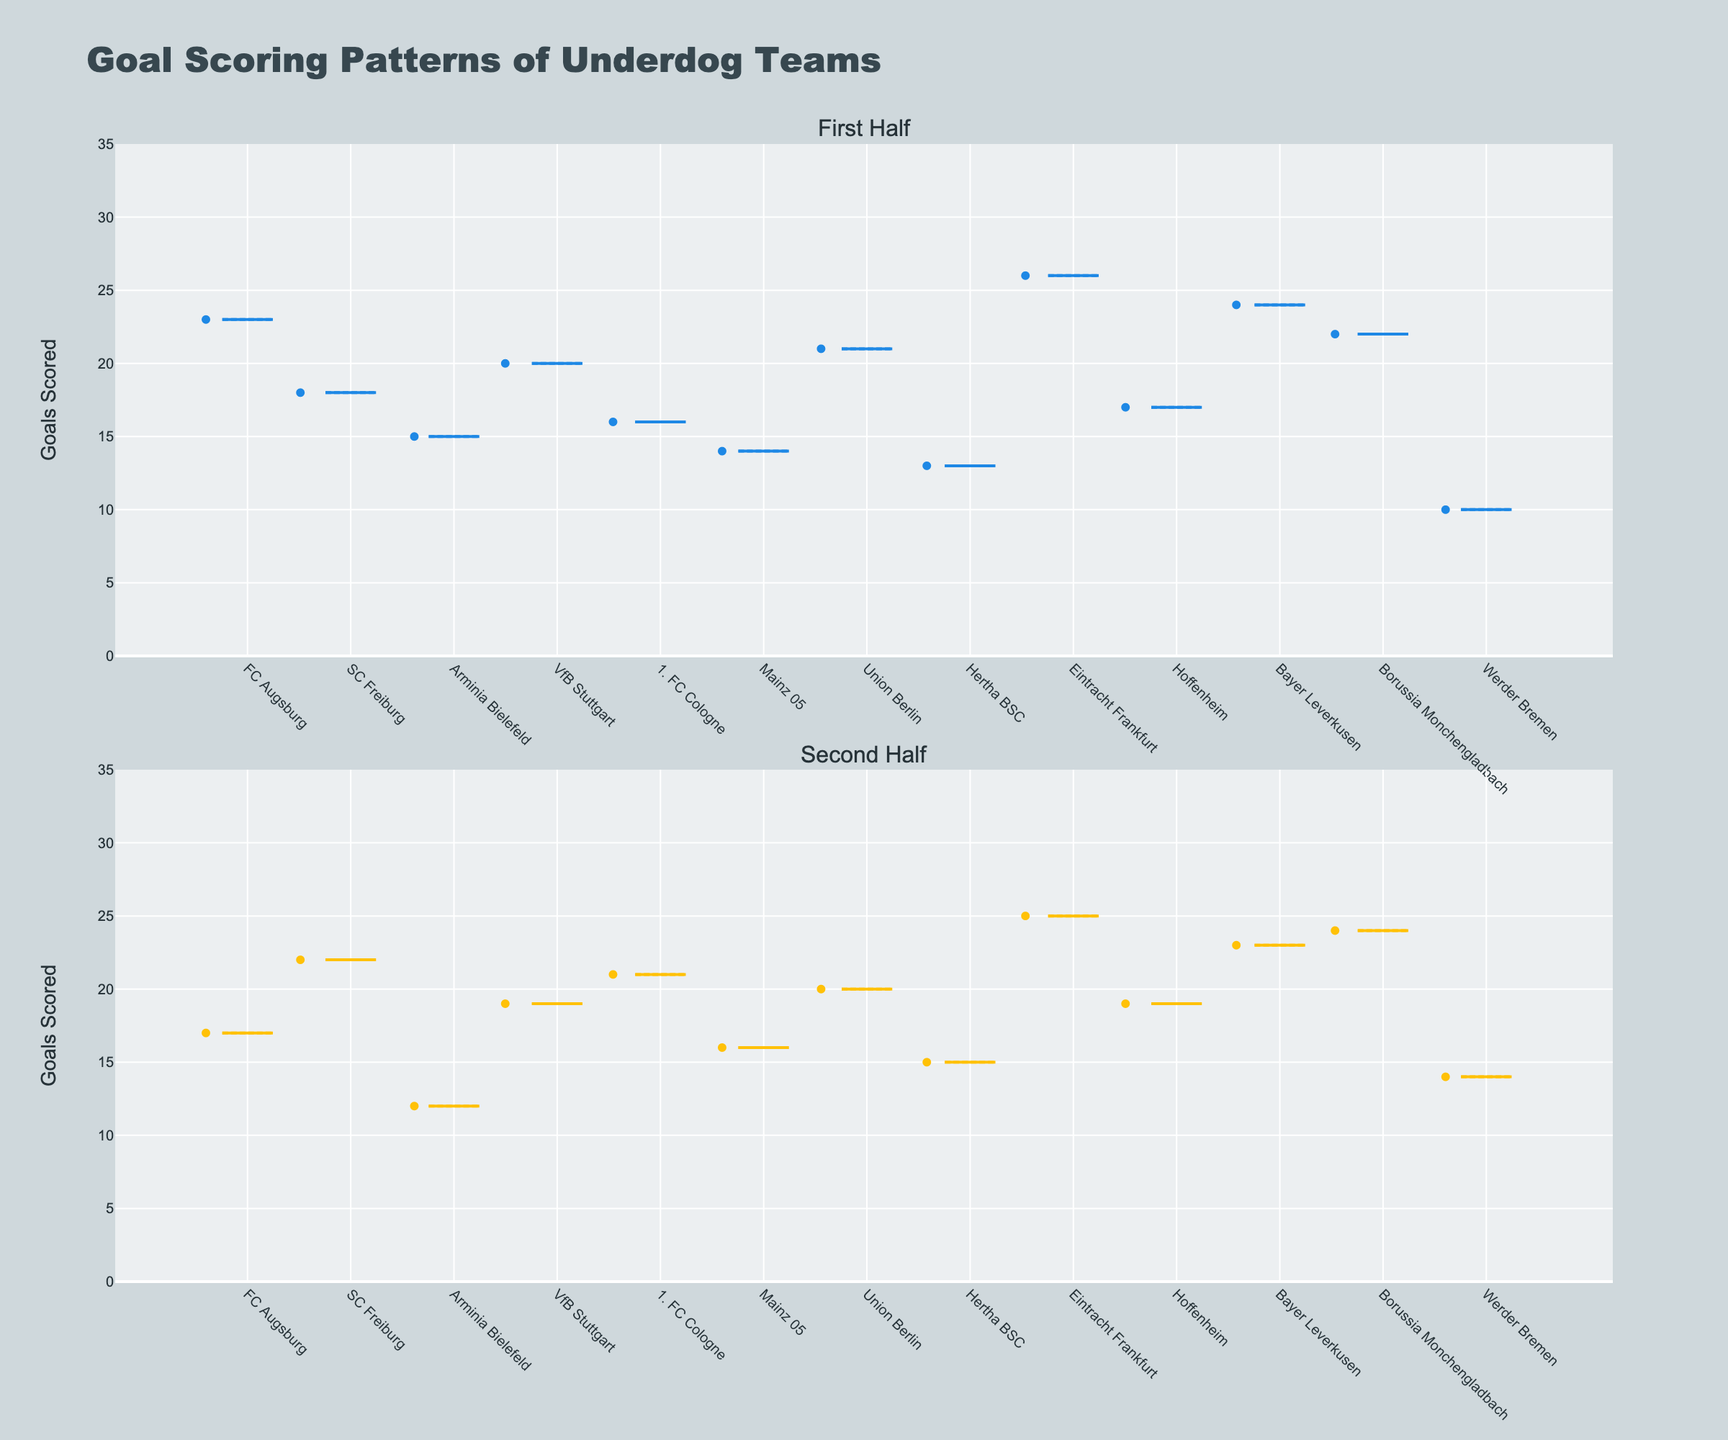Which season half has generally displayed greater spread in goal scoring? By comparing the size of the interquartile ranges (IQR) in both the "First Half" and "Second Half" box plots, we can assess spread. The "First Half" shows a greater spread as the IQR appears wider than the "Second Half".
Answer: First Half What is the median number of goals scored by underdog teams in the second half? Observing the central line in the "Second Half" box plot, which represents the median value, we estimate the median number of goals scored.
Answer: Around 19 goals Which team scored the highest number of goals in the first half? By looking at the maximum whisker and points in the "First Half" box plot, we identify that Eintracht Frankfurt has the highest number of goals scored.
Answer: Eintracht Frankfurt How does the median goals scored by underdog teams in the first half compare to the second half? Comparing the central lines (medians) in both “First Half” and “Second Half” box plots, the first half appears slightly higher than the second half. The first half has a median around 19-20, while the second half has around 18-19.
Answer: First Half is slightly higher Which team showed the most significant drop in goals scored between the first and second halves? By identifying the difference in goals between halves for each team in the box plot, Arminia Bielefeld stands out, dropping from 15 to 12 goals.
Answer: Arminia Bielefeld What color represents the second half goal scoring patterns? Observing the box plot colors, the second half is shown in a yellow hue, while the first half is blue.
Answer: Yellow Are there any teams whose goal scoring remained relatively stable between the two halves of the season? By comparing the positions of the data points in both plots, we find VfB Stuttgart has a very small difference in goals between halves, indicating stability.
Answer: VfB Stuttgart Which team scored the least number of goals in the first half? Referring to the minimum whisker and points in the "First Half" box plot, Werder Bremen scored the least number of goals.
Answer: Werder Bremen 